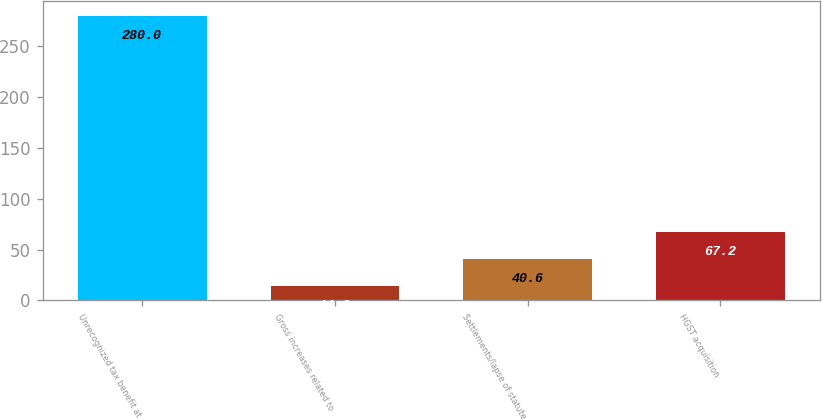Convert chart. <chart><loc_0><loc_0><loc_500><loc_500><bar_chart><fcel>Unrecognized tax benefit at<fcel>Gross increases related to<fcel>Settlements/lapse of statute<fcel>HGST acquisition<nl><fcel>280<fcel>14<fcel>40.6<fcel>67.2<nl></chart> 